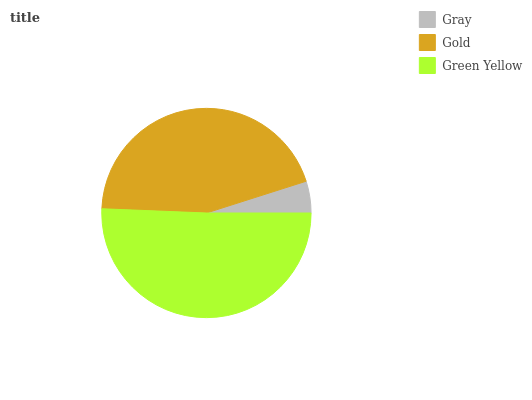Is Gray the minimum?
Answer yes or no. Yes. Is Green Yellow the maximum?
Answer yes or no. Yes. Is Gold the minimum?
Answer yes or no. No. Is Gold the maximum?
Answer yes or no. No. Is Gold greater than Gray?
Answer yes or no. Yes. Is Gray less than Gold?
Answer yes or no. Yes. Is Gray greater than Gold?
Answer yes or no. No. Is Gold less than Gray?
Answer yes or no. No. Is Gold the high median?
Answer yes or no. Yes. Is Gold the low median?
Answer yes or no. Yes. Is Green Yellow the high median?
Answer yes or no. No. Is Gray the low median?
Answer yes or no. No. 